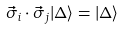<formula> <loc_0><loc_0><loc_500><loc_500>\vec { \sigma } _ { i } \cdot \vec { \sigma } _ { j } | \Delta \rangle = | \Delta \rangle</formula> 